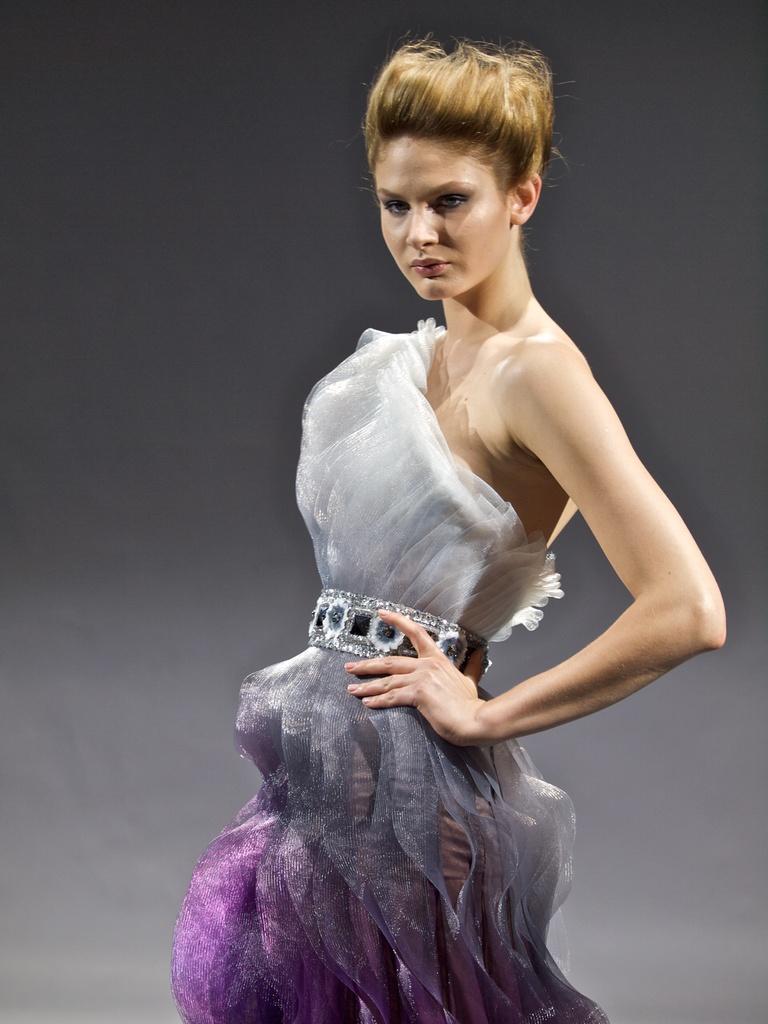Can you describe this image briefly? This image is taken indoors. In this image the background is gray in color. In the middle of the image of women in standing. 